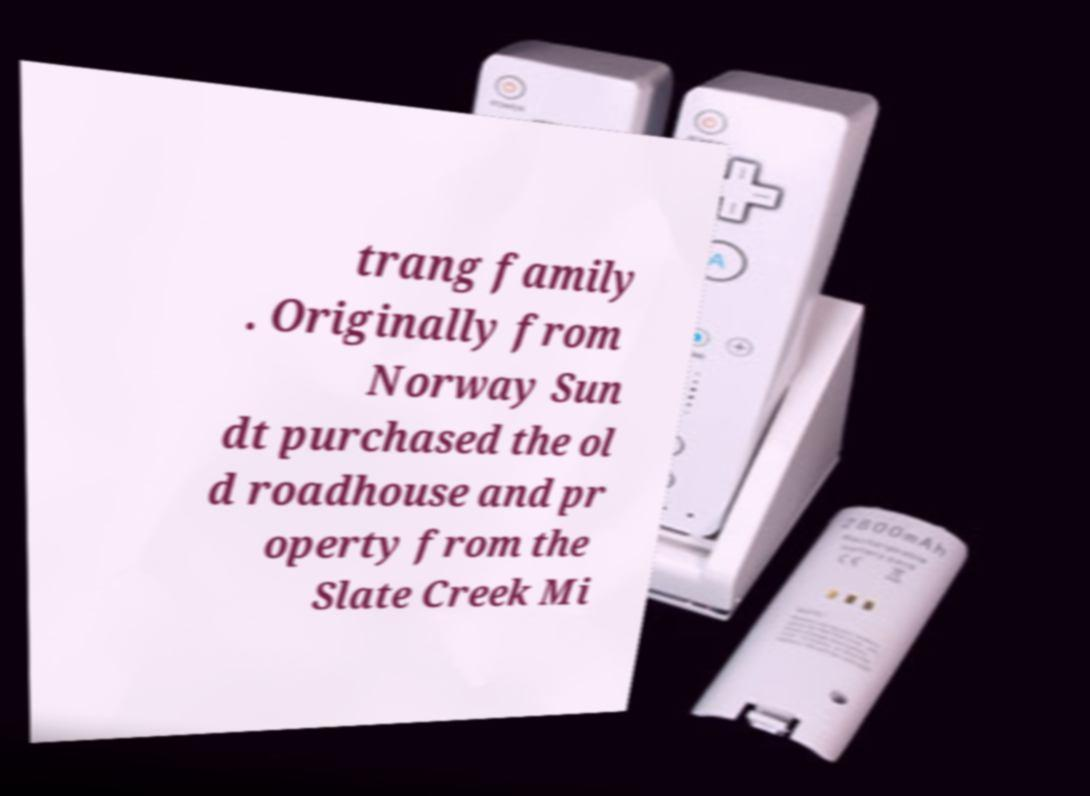Could you assist in decoding the text presented in this image and type it out clearly? trang family . Originally from Norway Sun dt purchased the ol d roadhouse and pr operty from the Slate Creek Mi 